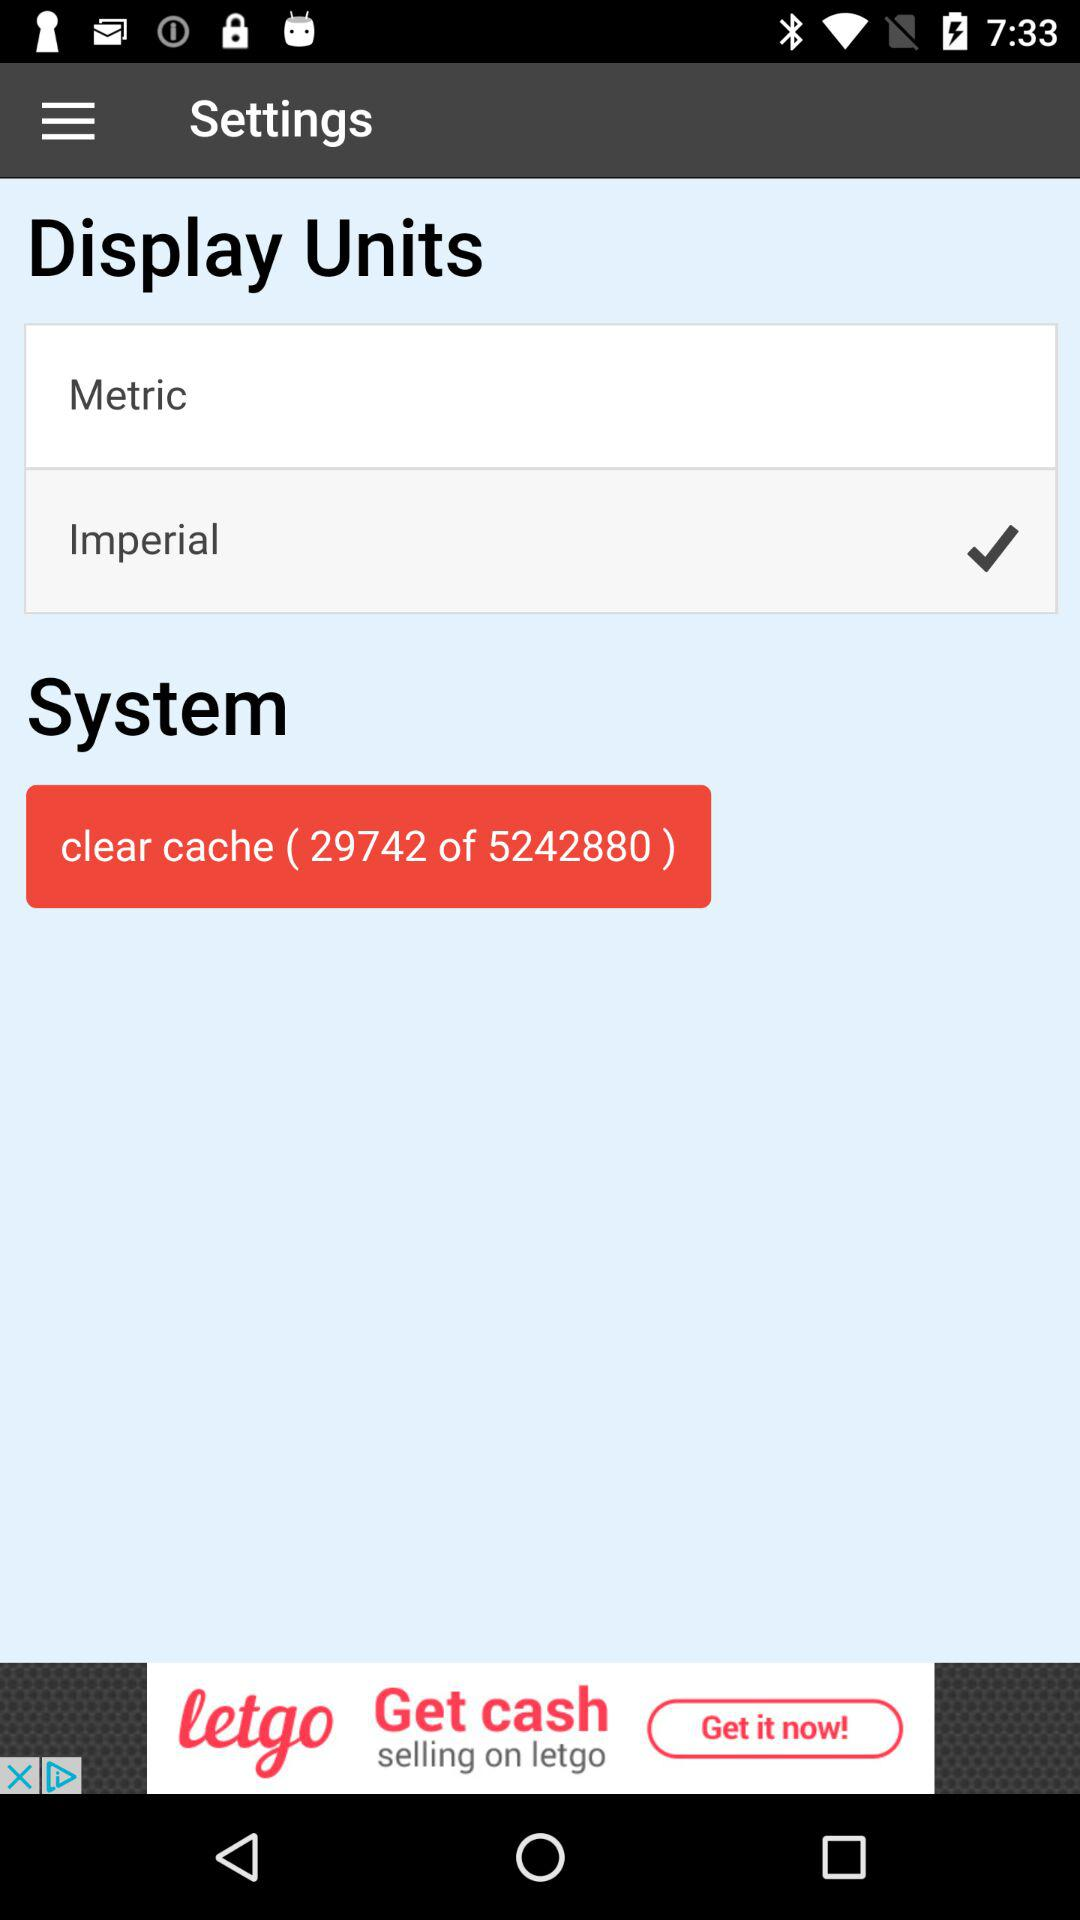Which display units are selected? The selected display unit is "Imperial". 